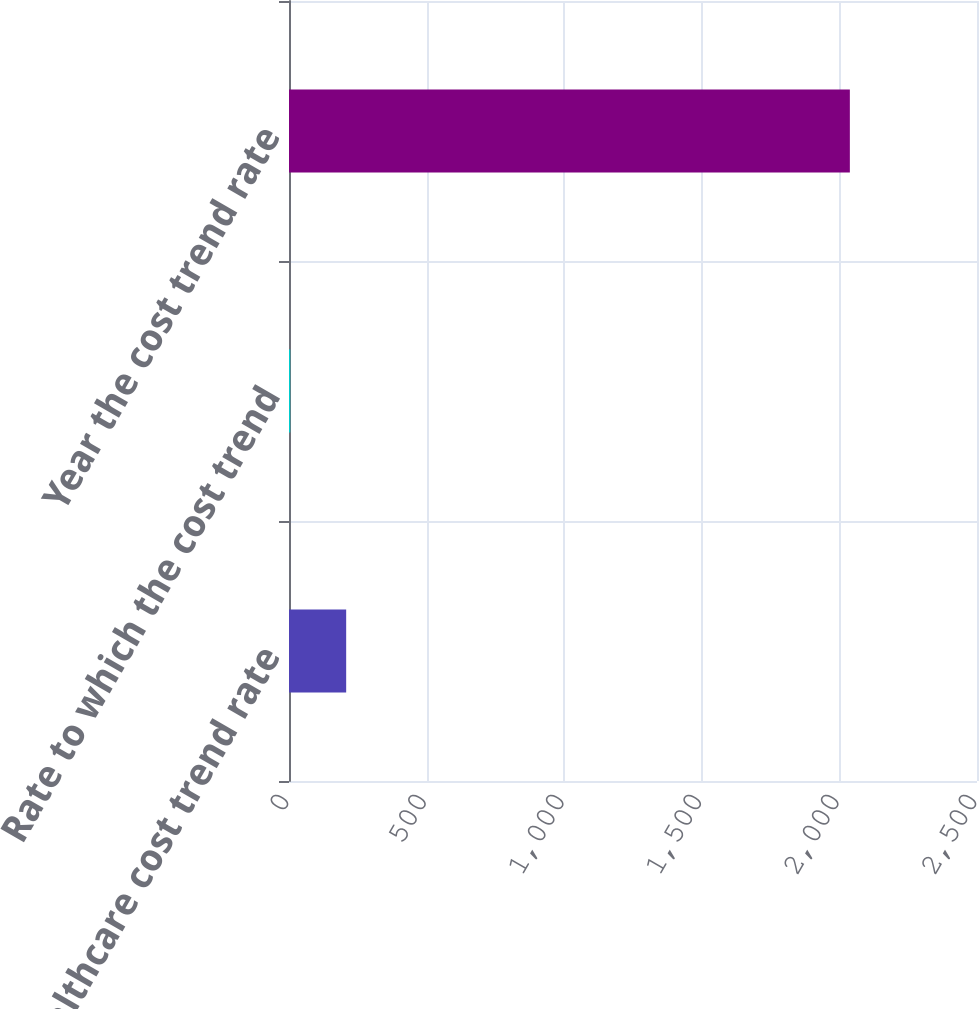<chart> <loc_0><loc_0><loc_500><loc_500><bar_chart><fcel>Healthcare cost trend rate<fcel>Rate to which the cost trend<fcel>Year the cost trend rate<nl><fcel>207.76<fcel>4.4<fcel>2038<nl></chart> 